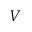Convert formula to latex. <formula><loc_0><loc_0><loc_500><loc_500>V</formula> 